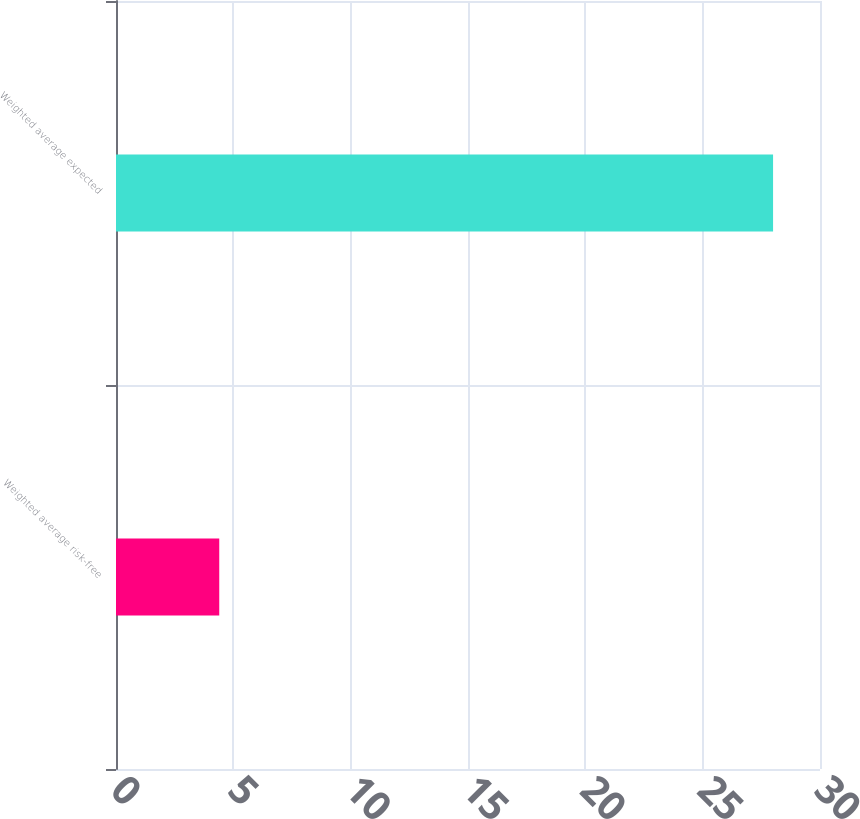<chart> <loc_0><loc_0><loc_500><loc_500><bar_chart><fcel>Weighted average risk-free<fcel>Weighted average expected<nl><fcel>4.4<fcel>28<nl></chart> 